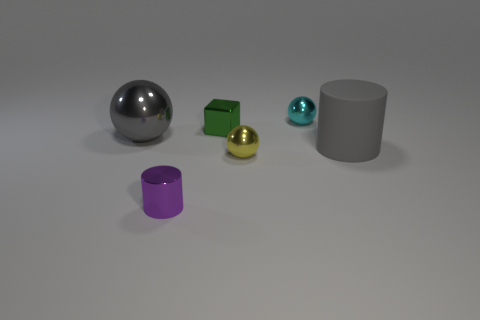What shape is the green shiny object? The green shiny object in the image is a cube. It has a distinctly geometric shape with six faces, each a perfect square, and sharp, defined edges, reflecting light uniformly on its surface. 